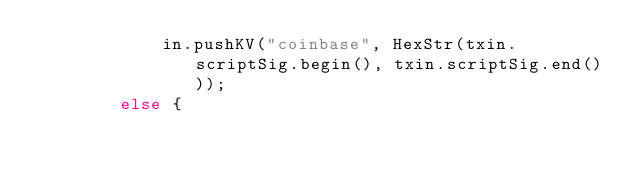<code> <loc_0><loc_0><loc_500><loc_500><_C++_>            in.pushKV("coinbase", HexStr(txin.scriptSig.begin(), txin.scriptSig.end()));
        else {</code> 